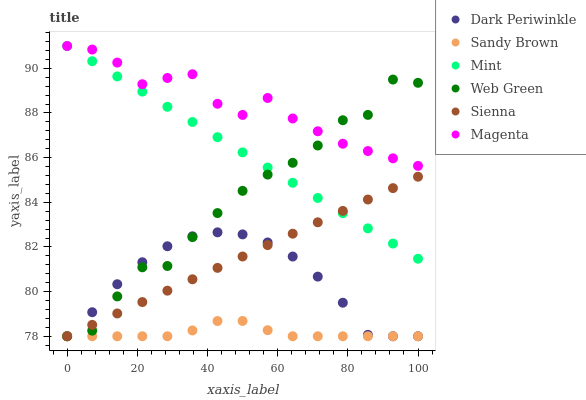Does Sandy Brown have the minimum area under the curve?
Answer yes or no. Yes. Does Magenta have the maximum area under the curve?
Answer yes or no. Yes. Does Web Green have the minimum area under the curve?
Answer yes or no. No. Does Web Green have the maximum area under the curve?
Answer yes or no. No. Is Sienna the smoothest?
Answer yes or no. Yes. Is Web Green the roughest?
Answer yes or no. Yes. Is Web Green the smoothest?
Answer yes or no. No. Is Sienna the roughest?
Answer yes or no. No. Does Sandy Brown have the lowest value?
Answer yes or no. Yes. Does Magenta have the lowest value?
Answer yes or no. No. Does Mint have the highest value?
Answer yes or no. Yes. Does Web Green have the highest value?
Answer yes or no. No. Is Sienna less than Magenta?
Answer yes or no. Yes. Is Magenta greater than Dark Periwinkle?
Answer yes or no. Yes. Does Web Green intersect Sienna?
Answer yes or no. Yes. Is Web Green less than Sienna?
Answer yes or no. No. Is Web Green greater than Sienna?
Answer yes or no. No. Does Sienna intersect Magenta?
Answer yes or no. No. 